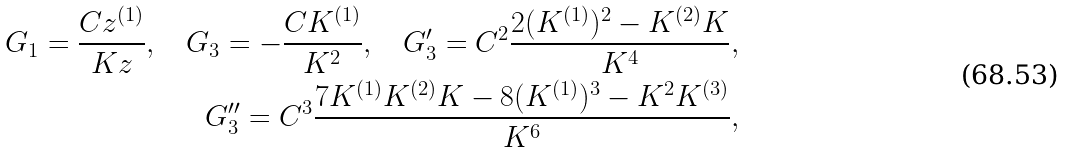<formula> <loc_0><loc_0><loc_500><loc_500>G _ { 1 } = \frac { C z ^ { ( 1 ) } } { K z } , \quad G _ { 3 } = - \frac { C K ^ { ( 1 ) } } { K ^ { 2 } } , \quad G _ { 3 } ^ { \prime } = C ^ { 2 } \frac { 2 ( K ^ { ( 1 ) } ) ^ { 2 } - K ^ { ( 2 ) } K } { K ^ { 4 } } , \\ G _ { 3 } ^ { \prime \prime } = C ^ { 3 } \frac { 7 K ^ { ( 1 ) } K ^ { ( 2 ) } K - 8 ( K ^ { ( 1 ) } ) ^ { 3 } - K ^ { 2 } K ^ { ( 3 ) } } { K ^ { 6 } } ,</formula> 